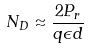<formula> <loc_0><loc_0><loc_500><loc_500>N _ { D } \approx \frac { 2 P _ { r } } { q \epsilon d }</formula> 